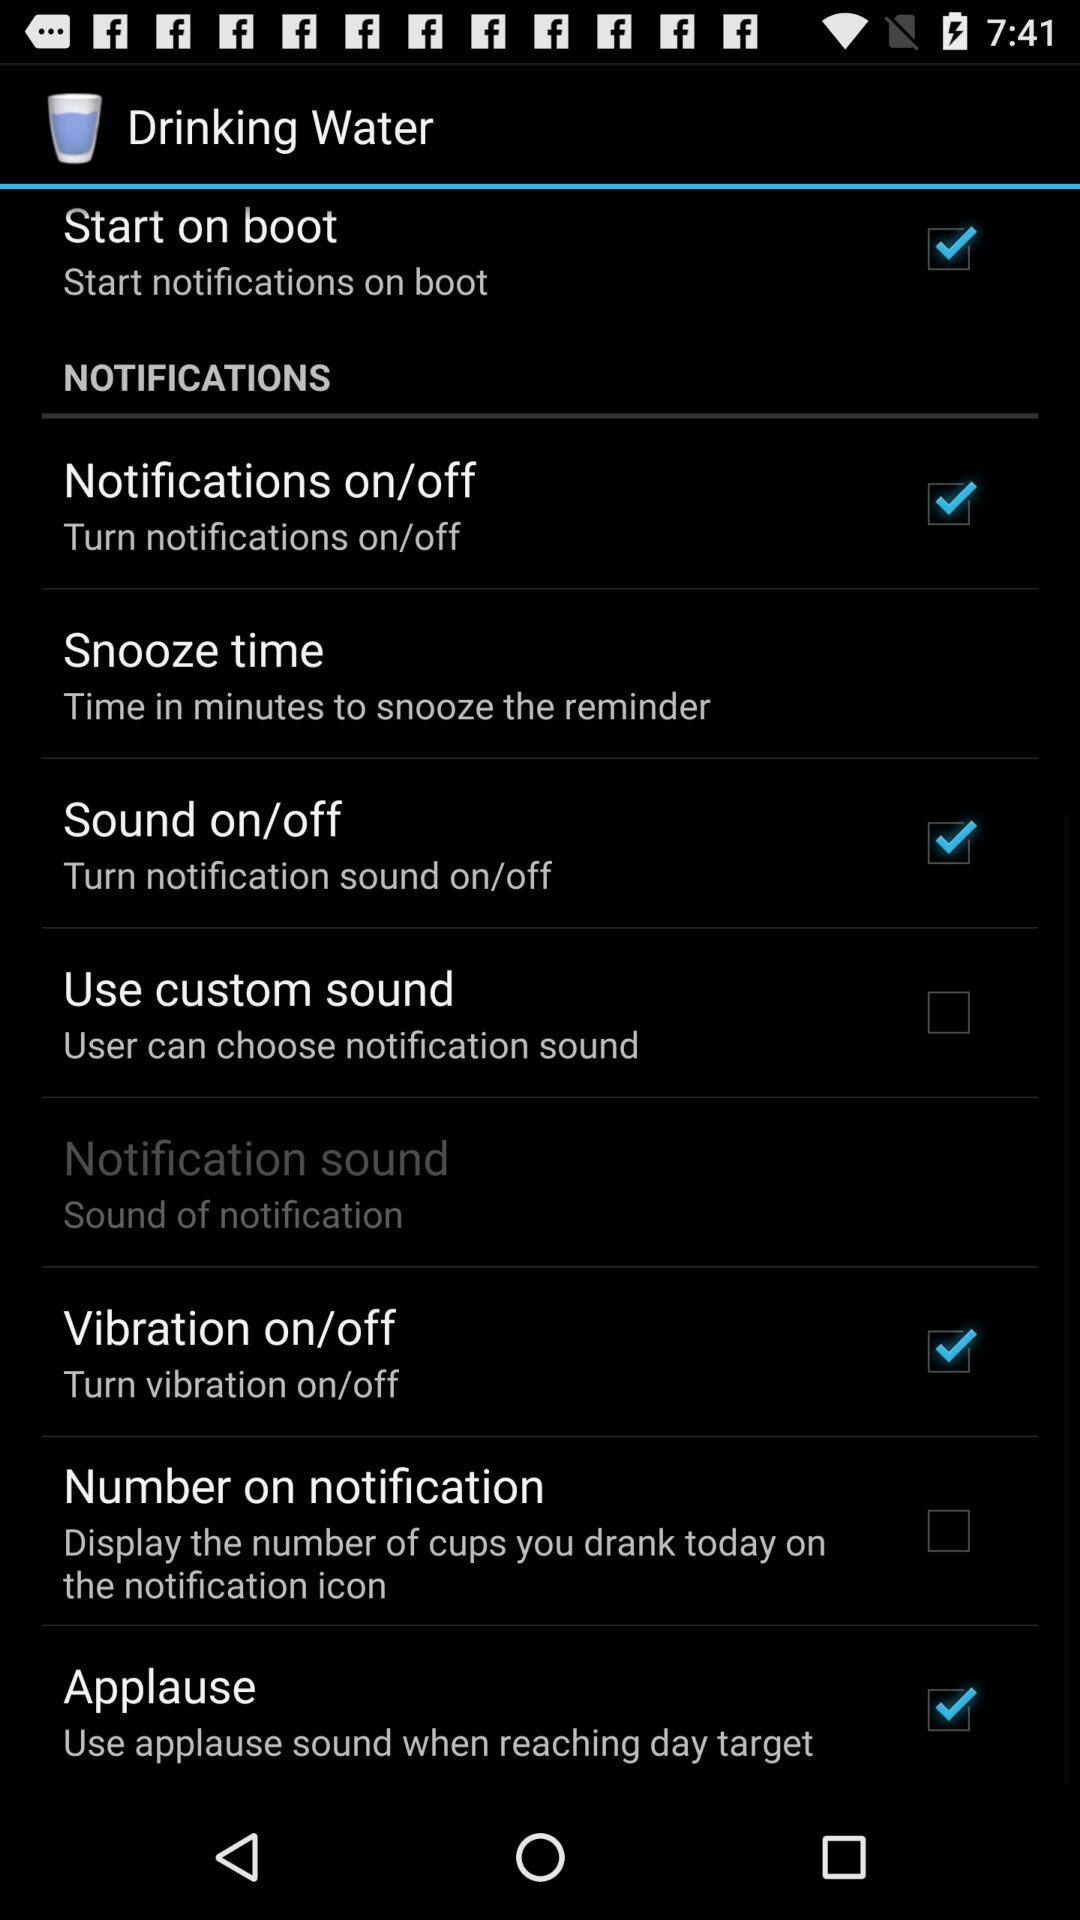Which option is not checked? The options that are not checked are "Use custom sound" and "Number on notification". 